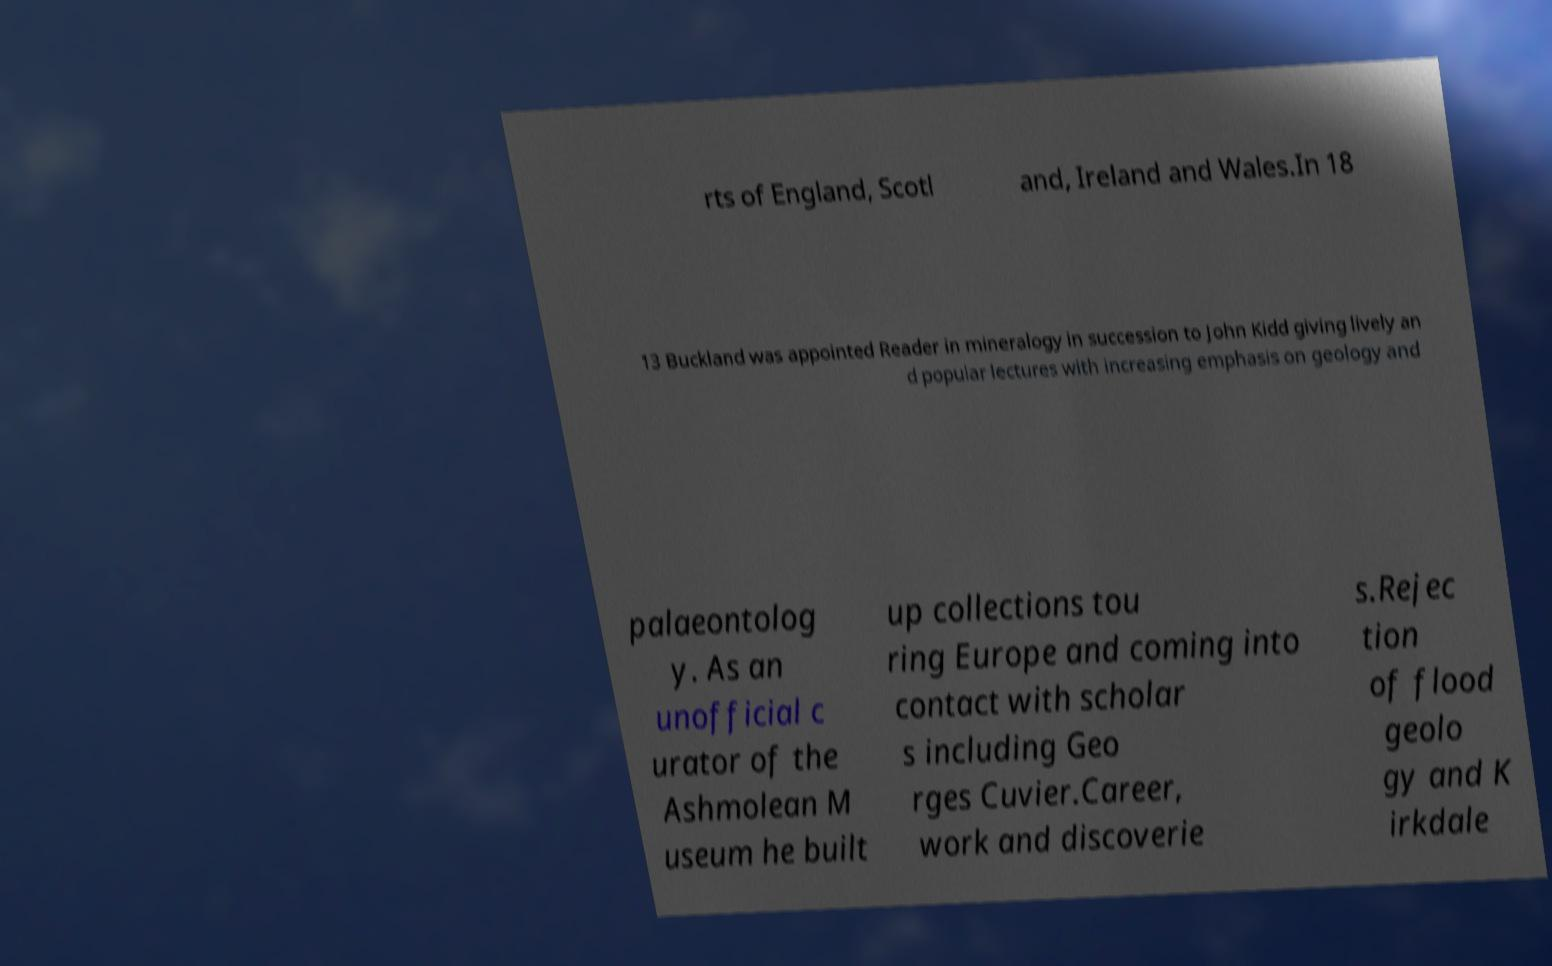Please identify and transcribe the text found in this image. rts of England, Scotl and, Ireland and Wales.In 18 13 Buckland was appointed Reader in mineralogy in succession to John Kidd giving lively an d popular lectures with increasing emphasis on geology and palaeontolog y. As an unofficial c urator of the Ashmolean M useum he built up collections tou ring Europe and coming into contact with scholar s including Geo rges Cuvier.Career, work and discoverie s.Rejec tion of flood geolo gy and K irkdale 